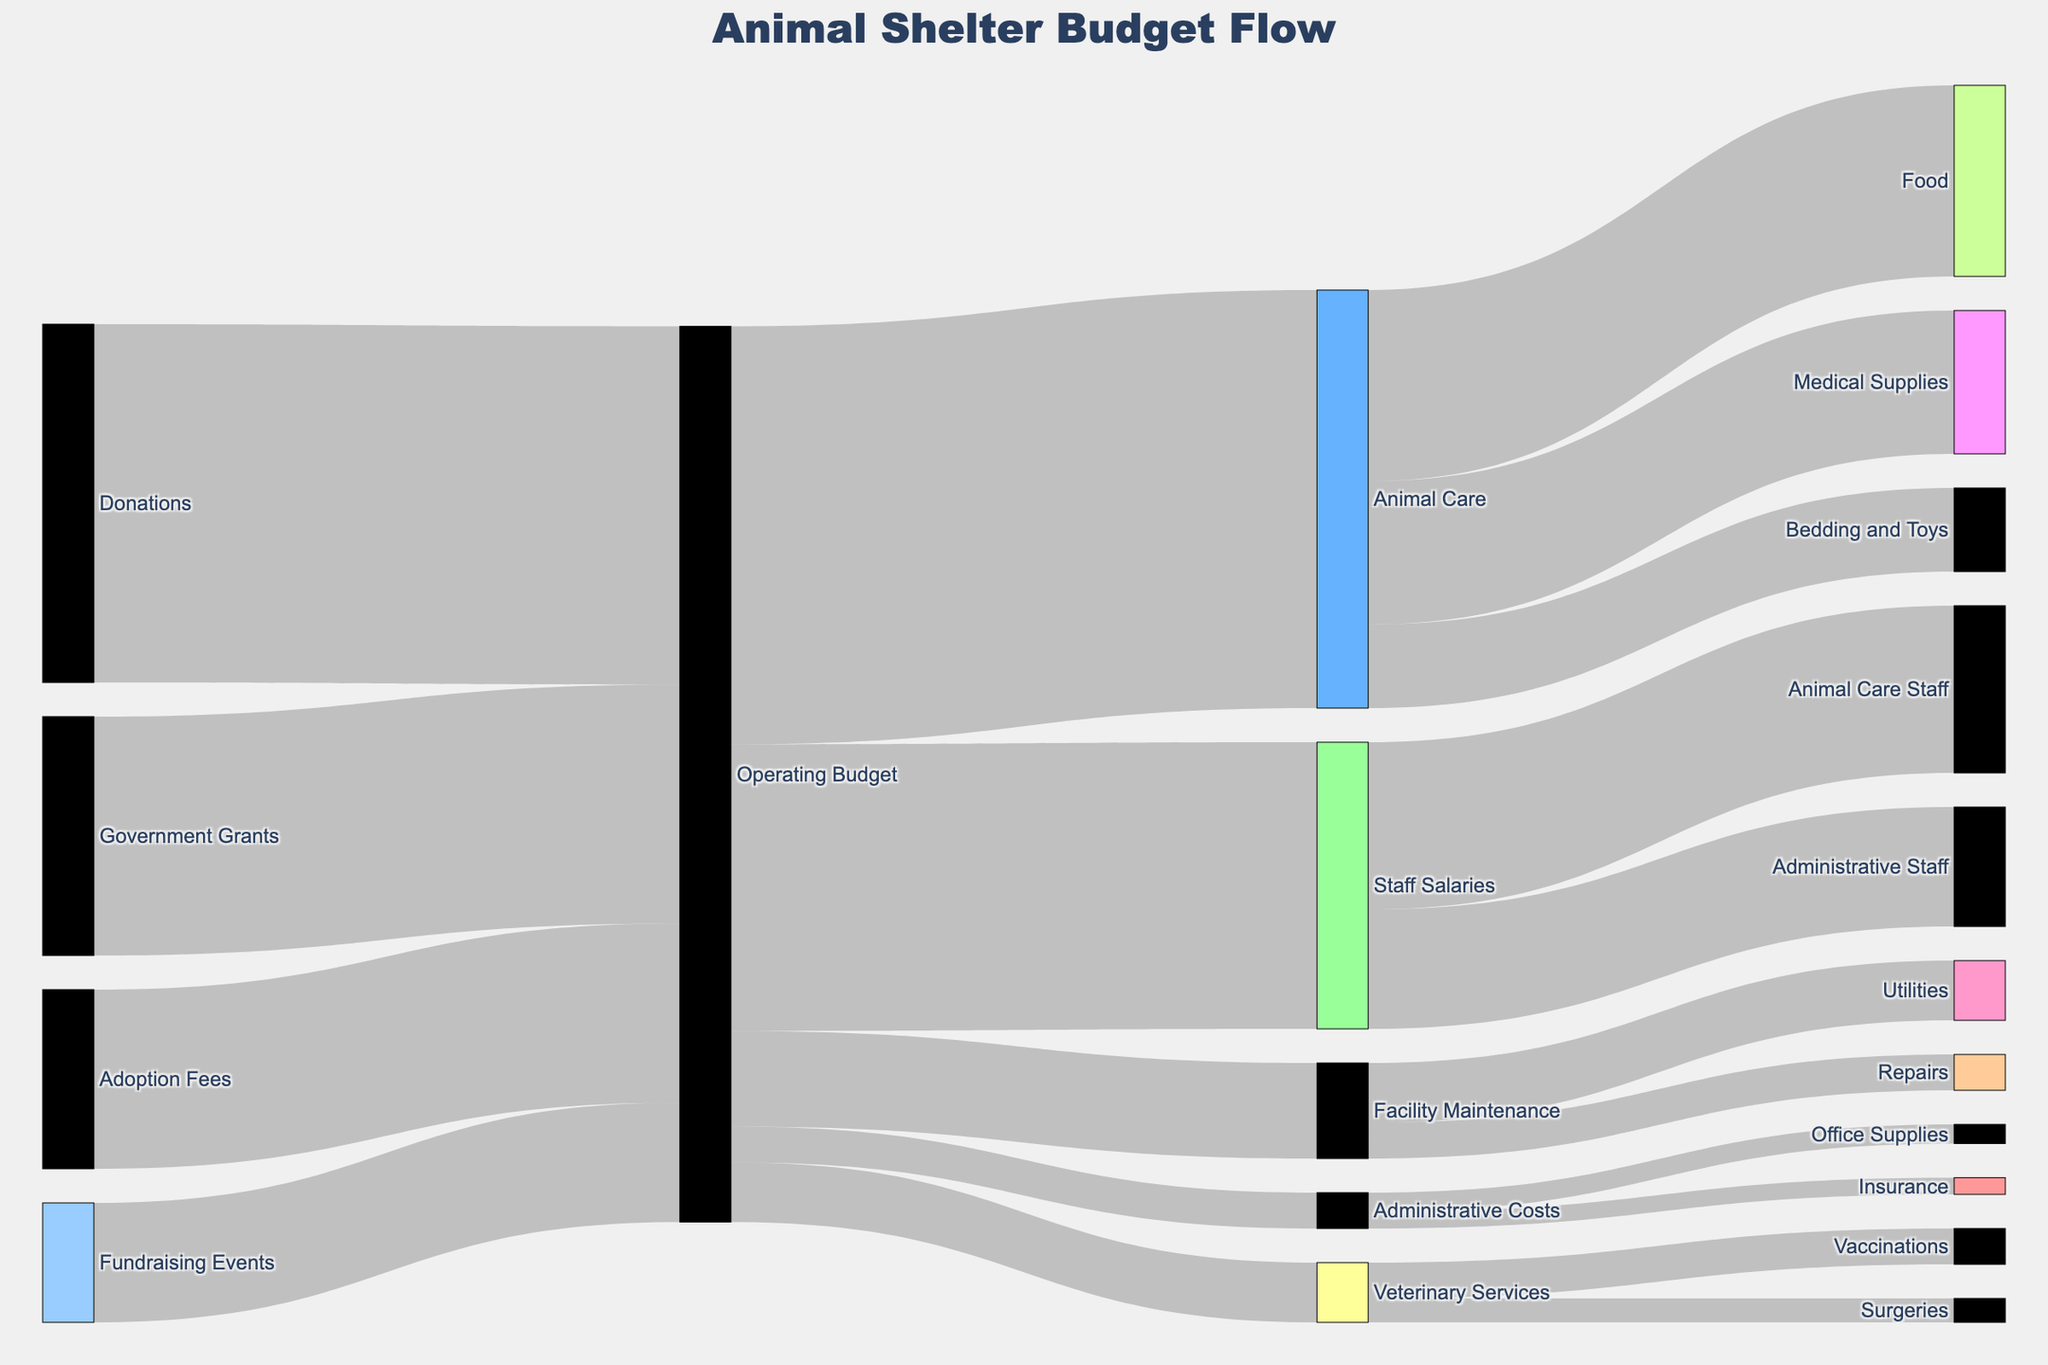What are the main income sources for the animal shelter? The main income sources are visible on the left side of the Sankey diagram - Donations, Government Grants, Adoption Fees, and Fundraising Events.
Answer: Donations, Government Grants, Adoption Fees, Fundraising Events What is the largest expenditure category within the Operating Budget? Examine the width of the flows from the Operating Budget. The widest flow is towards Animal Care.
Answer: Animal Care How much money is allocated to Staff Salaries from the Operating Budget? Follow the flow from Operating Budget to Staff Salaries and note the value at this connection.
Answer: $120,000 Compare the amount spent on Veterinary Services and Facility Maintenance. Which one is higher? Trace the flows from the Operating Budget to both Veterinary Services and Facility Maintenance, then compare their values. Facility Maintenance is higher.
Answer: Facility Maintenance What percentage of the Animal Care budget is spent on Food? First, identify the total Animal Care budget, which is $175,000. The amount spent on food is $80,000. Calculate the percentage: (80,000 / 175,000) * 100 = 45.7%.
Answer: 45.7% What is the combined total of funds coming from Donations and Government Grants? Find the values for Donations ($150,000) and Government Grants ($100,000), then add them together: $150,000 + $100,000 = $250,000.
Answer: $250,000 How much of the Animal Care budget is allocated to Medical Supplies and Bedding and Toys combined? Identify the values for Medical Supplies ($60,000) and Bedding and Toys ($35,000), then sum them up: $60,000 + $35,000 = $95,000.
Answer: $95,000 What is the smallest spending category under Administrative Costs? Compare the flows from Administrative Costs. Office Supplies has a smaller flow ($8,000) compared to Insurance ($7,000).
Answer: Insurance Which source contributes the least to the Operating Budget? What is the amount? Compare the values of all income sources. The smallest contribution is from Fundraising Events at $50,000.
Answer: Fundraising Events, $50,000 How does the amount spent on Vaccinations compare to the amount spent on Repairs? Find the values for Vaccinations ($15,000) and Repairs ($15,000). Both amounts are equal.
Answer: Equal 